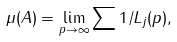<formula> <loc_0><loc_0><loc_500><loc_500>\mu ( A ) = \lim _ { p \rightarrow \infty } \sum 1 / L _ { j } ( p ) ,</formula> 